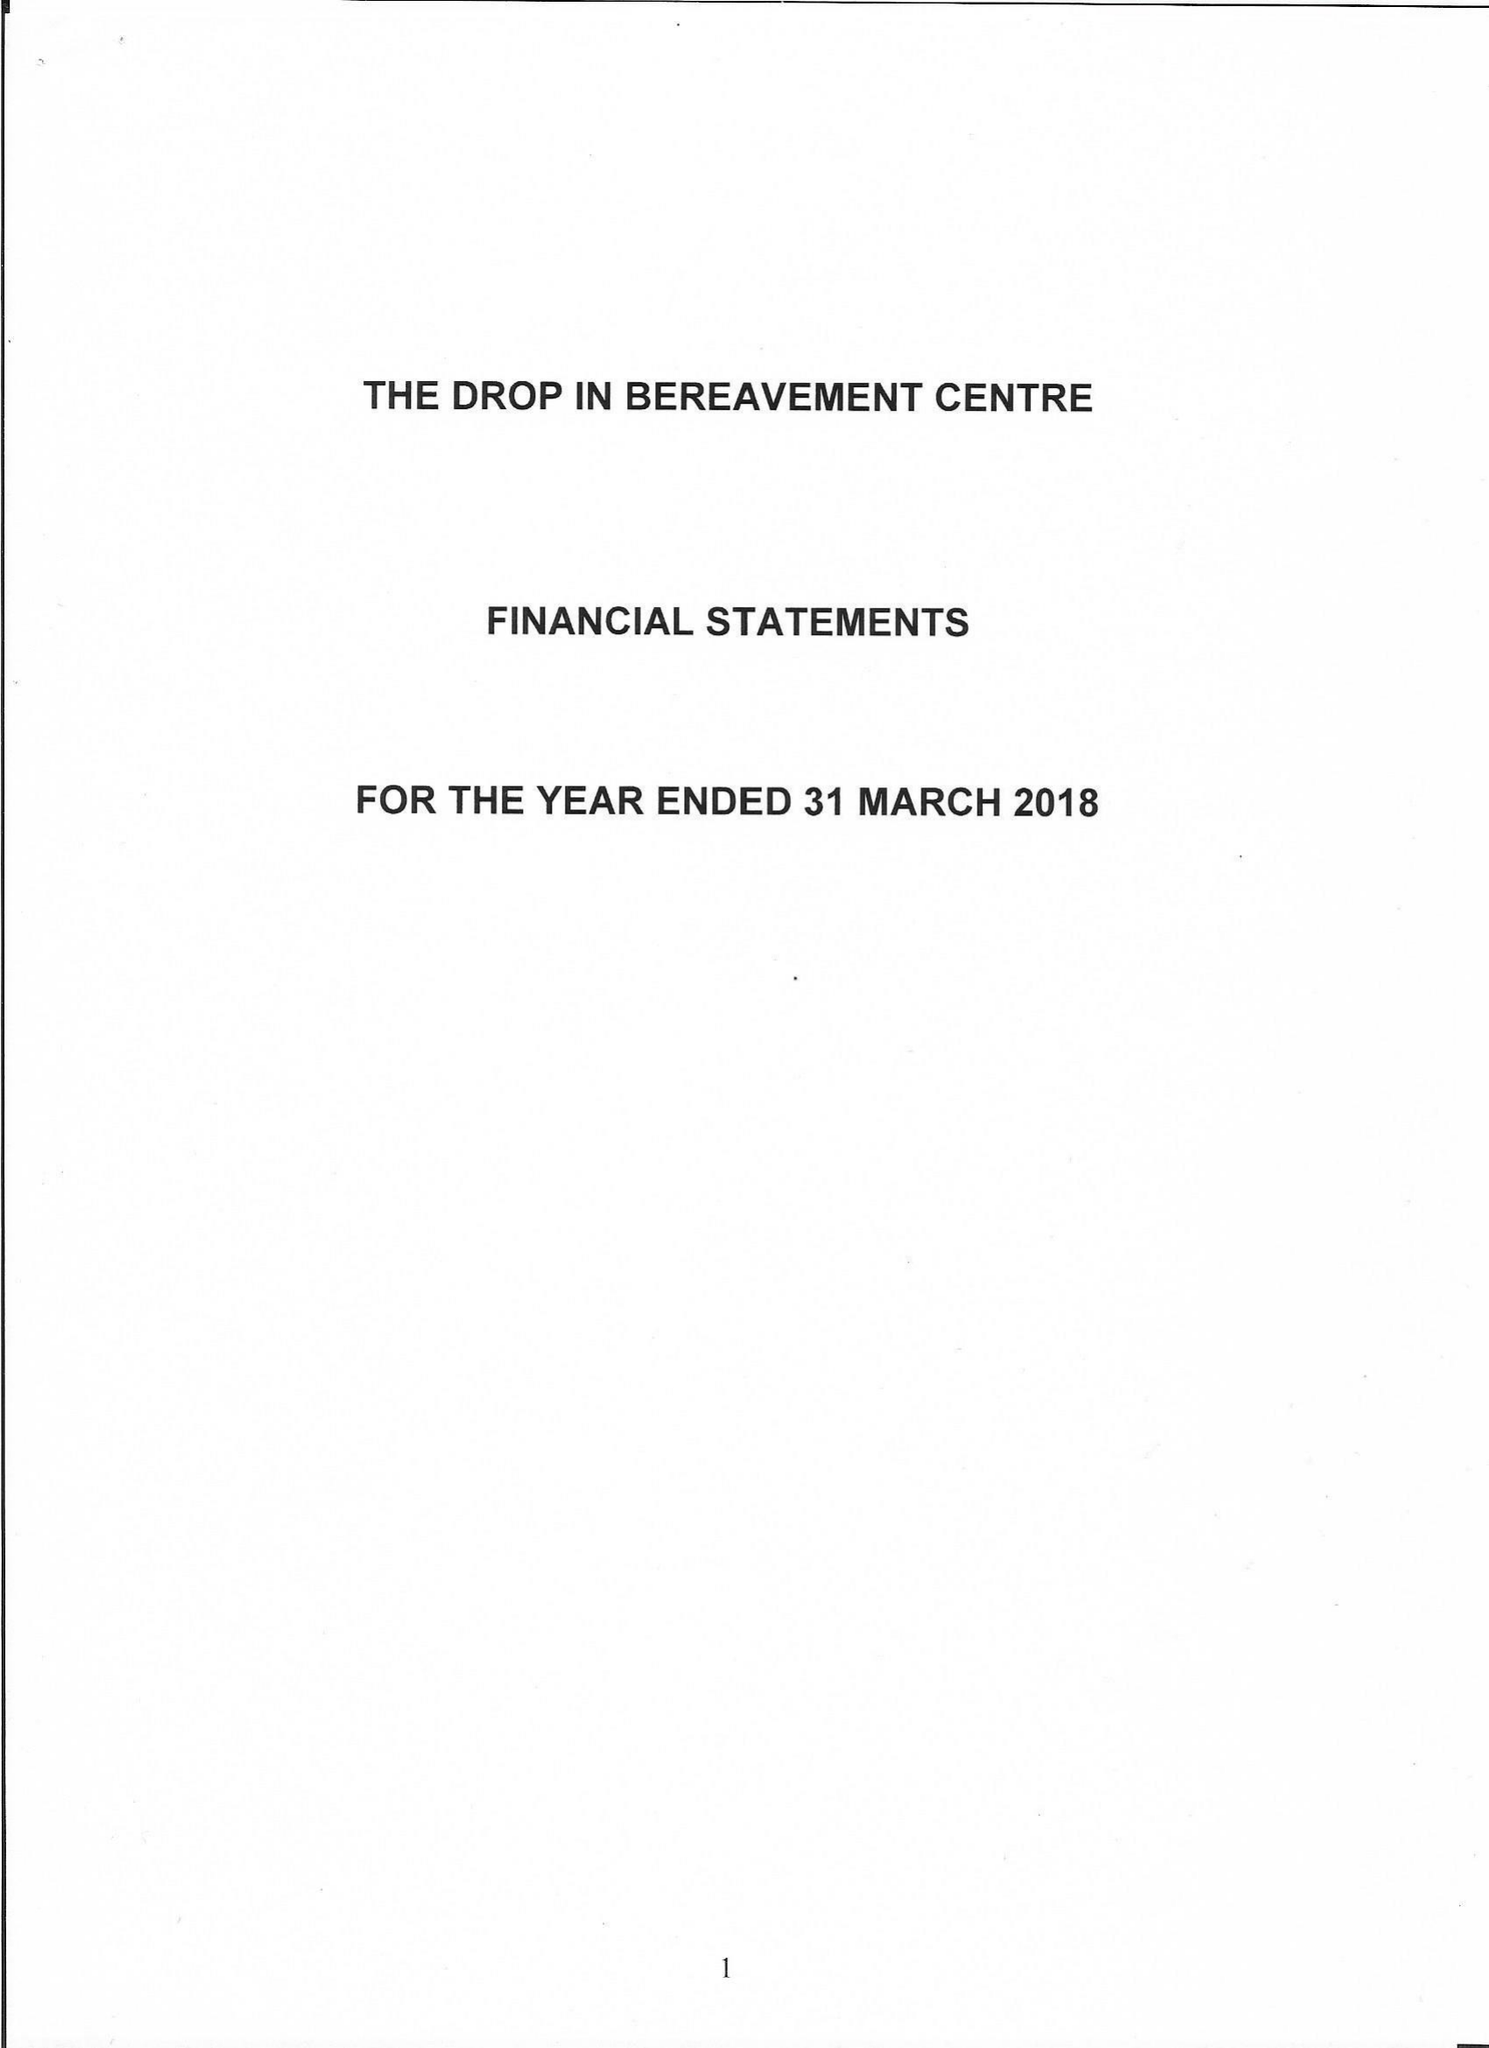What is the value for the address__postcode?
Answer the question using a single word or phrase. E13 0HA 